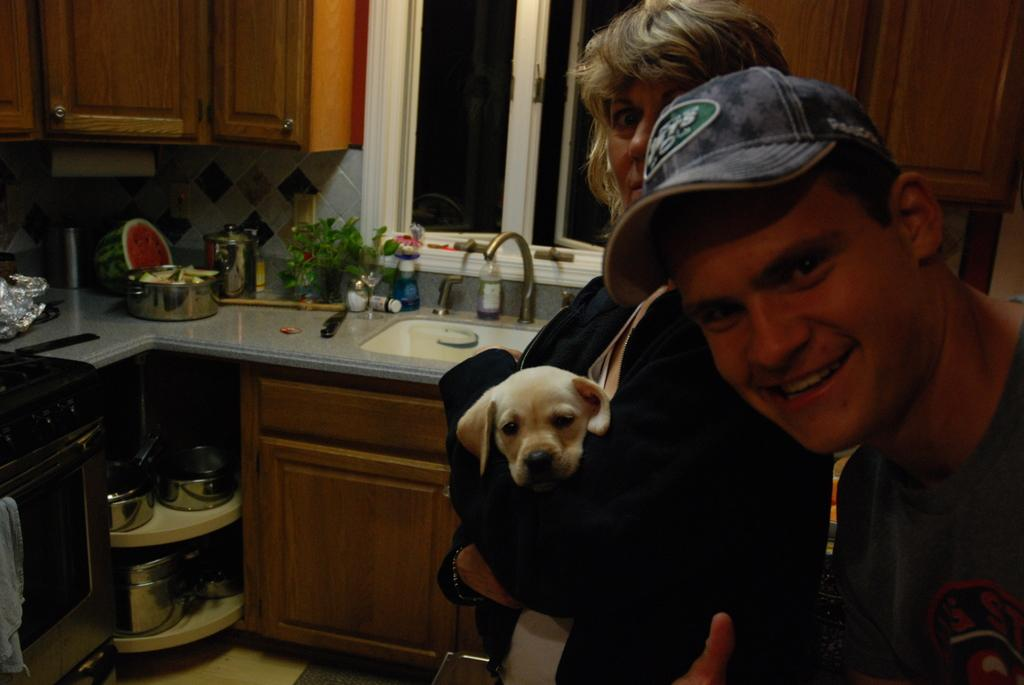How many people are present in the image? There are two people in the image, a man and a woman. What is the woman holding in the image? The woman is holding a dog. What can be seen in the background of the image? There is a kitchen countertop, a sink, a tap, and a window in the background of the image. What might the woman be doing with the dog? The woman might be holding or petting the dog. What type of comb is the man using on his feet in the image? There is no comb or reference to feet in the image; the man is simply standing next to the woman holding a dog. 